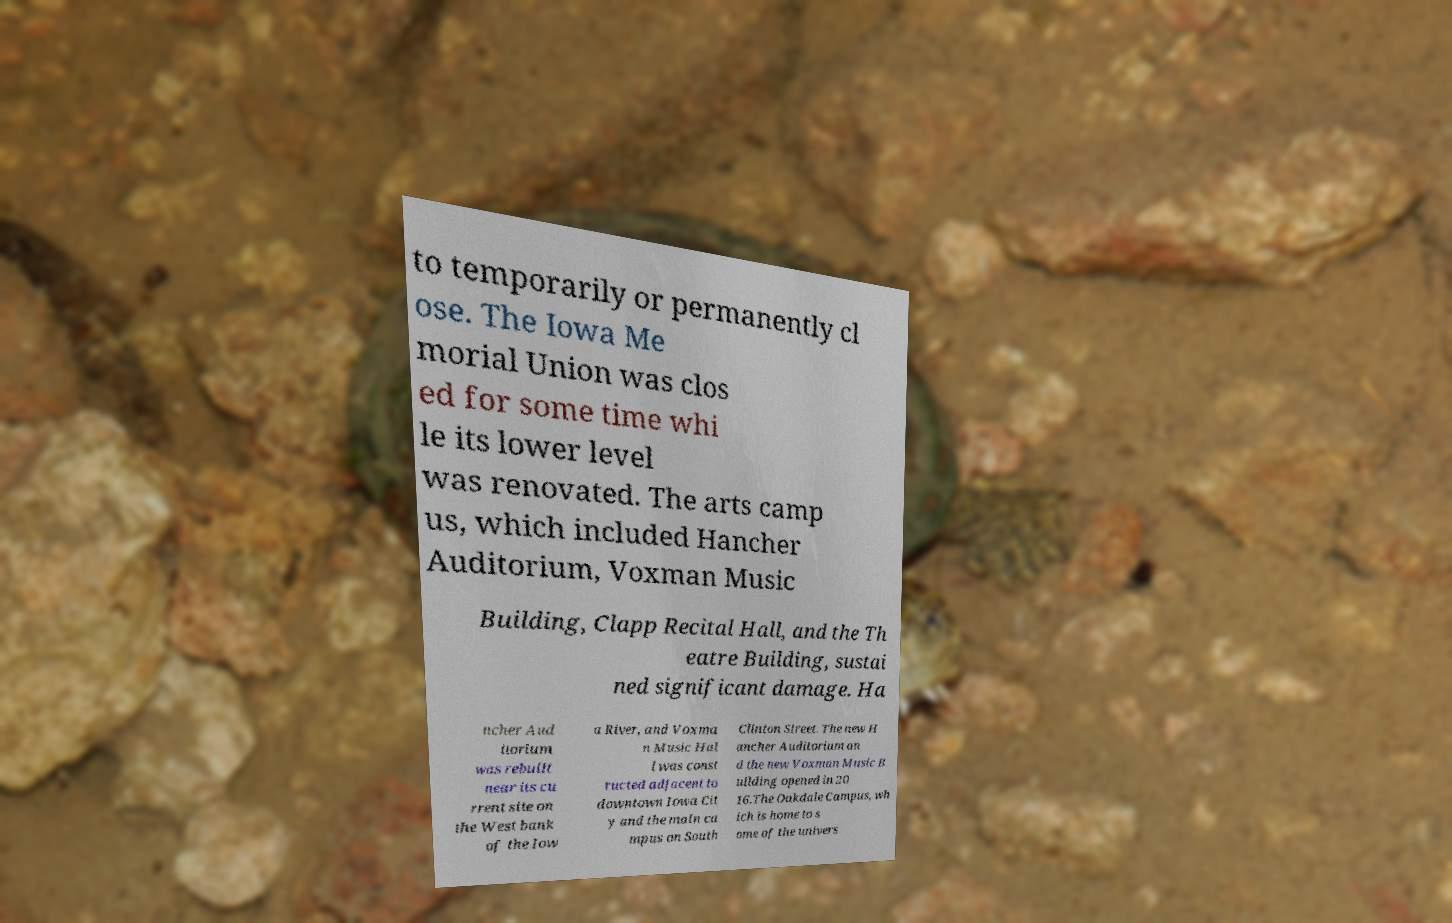Please read and relay the text visible in this image. What does it say? to temporarily or permanently cl ose. The Iowa Me morial Union was clos ed for some time whi le its lower level was renovated. The arts camp us, which included Hancher Auditorium, Voxman Music Building, Clapp Recital Hall, and the Th eatre Building, sustai ned significant damage. Ha ncher Aud itorium was rebuilt near its cu rrent site on the West bank of the Iow a River, and Voxma n Music Hal l was const ructed adjacent to downtown Iowa Cit y and the main ca mpus on South Clinton Street. The new H ancher Auditorium an d the new Voxman Music B uilding opened in 20 16.The Oakdale Campus, wh ich is home to s ome of the univers 